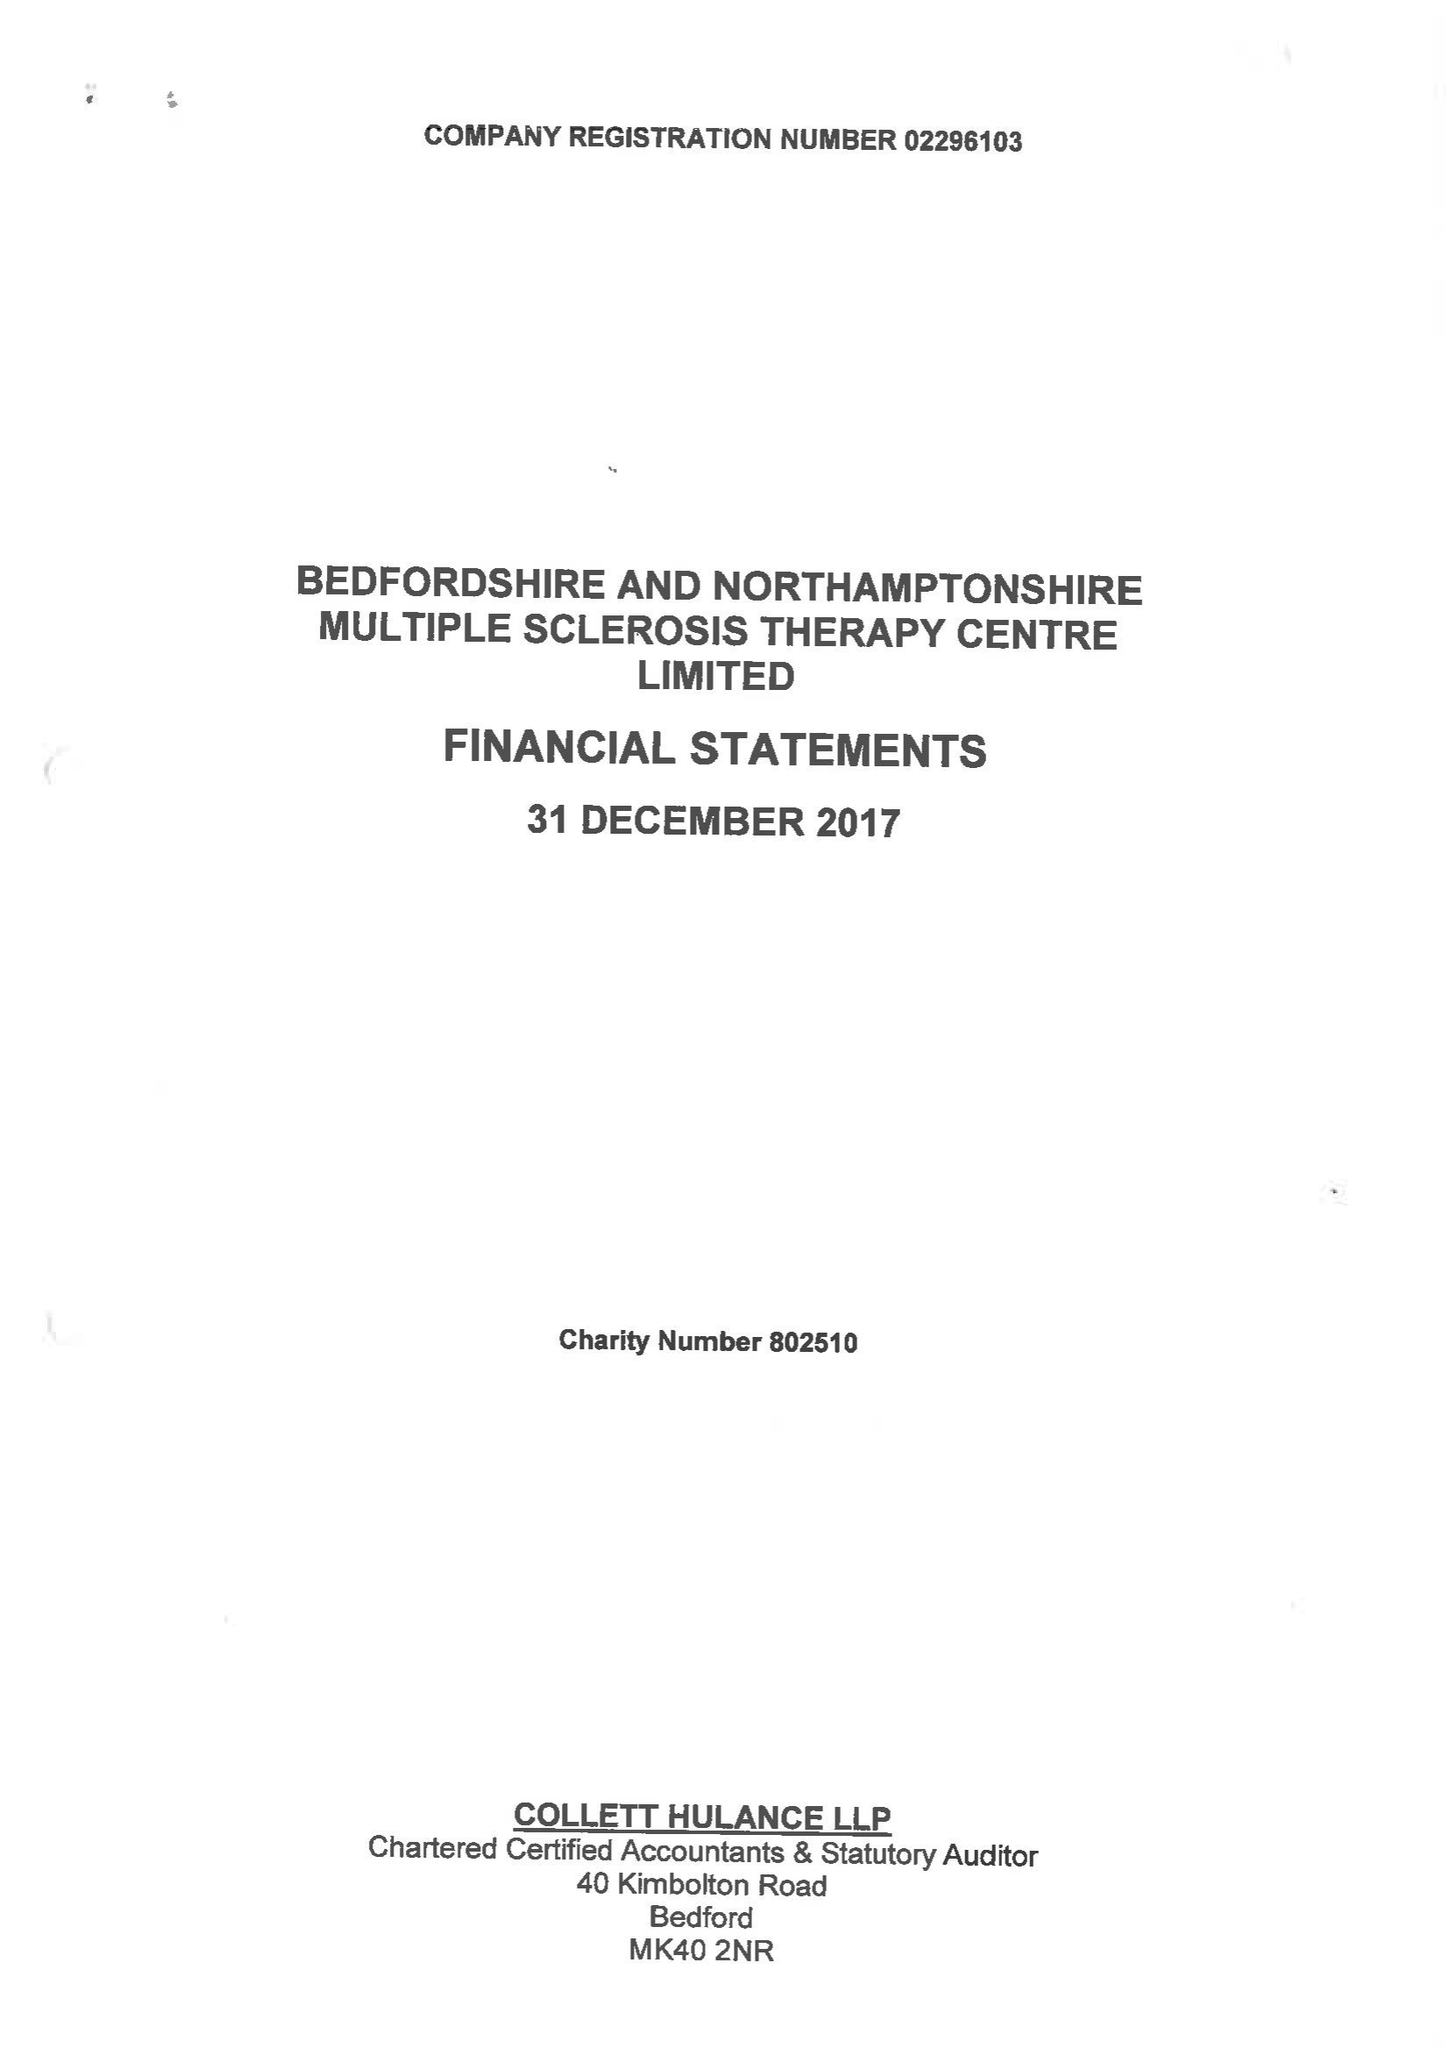What is the value for the income_annually_in_british_pounds?
Answer the question using a single word or phrase. 484116.00 